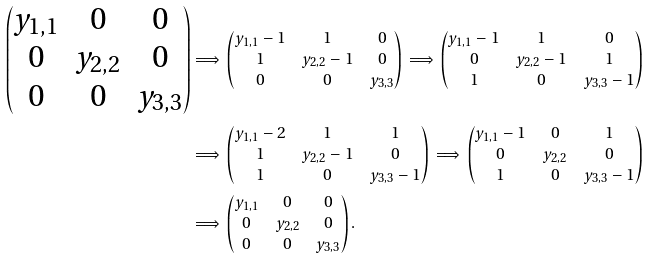Convert formula to latex. <formula><loc_0><loc_0><loc_500><loc_500>\begin{pmatrix} y _ { 1 , 1 } & 0 & 0 \\ 0 & y _ { 2 , 2 } & 0 \\ 0 & 0 & y _ { 3 , 3 } \end{pmatrix} & \Longrightarrow \, \begin{pmatrix} y _ { 1 , 1 } - 1 & 1 & 0 \\ 1 & y _ { 2 , 2 } - 1 & 0 \\ 0 & 0 & y _ { 3 , 3 } \end{pmatrix} \, \Longrightarrow \, \begin{pmatrix} y _ { 1 , 1 } - 1 & 1 & 0 \\ 0 & y _ { 2 , 2 } - 1 & 1 \\ 1 & 0 & y _ { 3 , 3 } - 1 \end{pmatrix} \\ & \Longrightarrow \, \begin{pmatrix} y _ { 1 , 1 } - 2 & 1 & 1 \\ 1 & y _ { 2 , 2 } - 1 & 0 \\ 1 & 0 & y _ { 3 , 3 } - 1 \end{pmatrix} \, \Longrightarrow \, \begin{pmatrix} y _ { 1 , 1 } - 1 & 0 & 1 \\ 0 & y _ { 2 , 2 } & 0 \\ 1 & 0 & y _ { 3 , 3 } - 1 \end{pmatrix} \\ & \Longrightarrow \, \begin{pmatrix} y _ { 1 , 1 } & 0 & 0 \\ 0 & y _ { 2 , 2 } & 0 \\ 0 & 0 & y _ { 3 , 3 } \end{pmatrix} .</formula> 